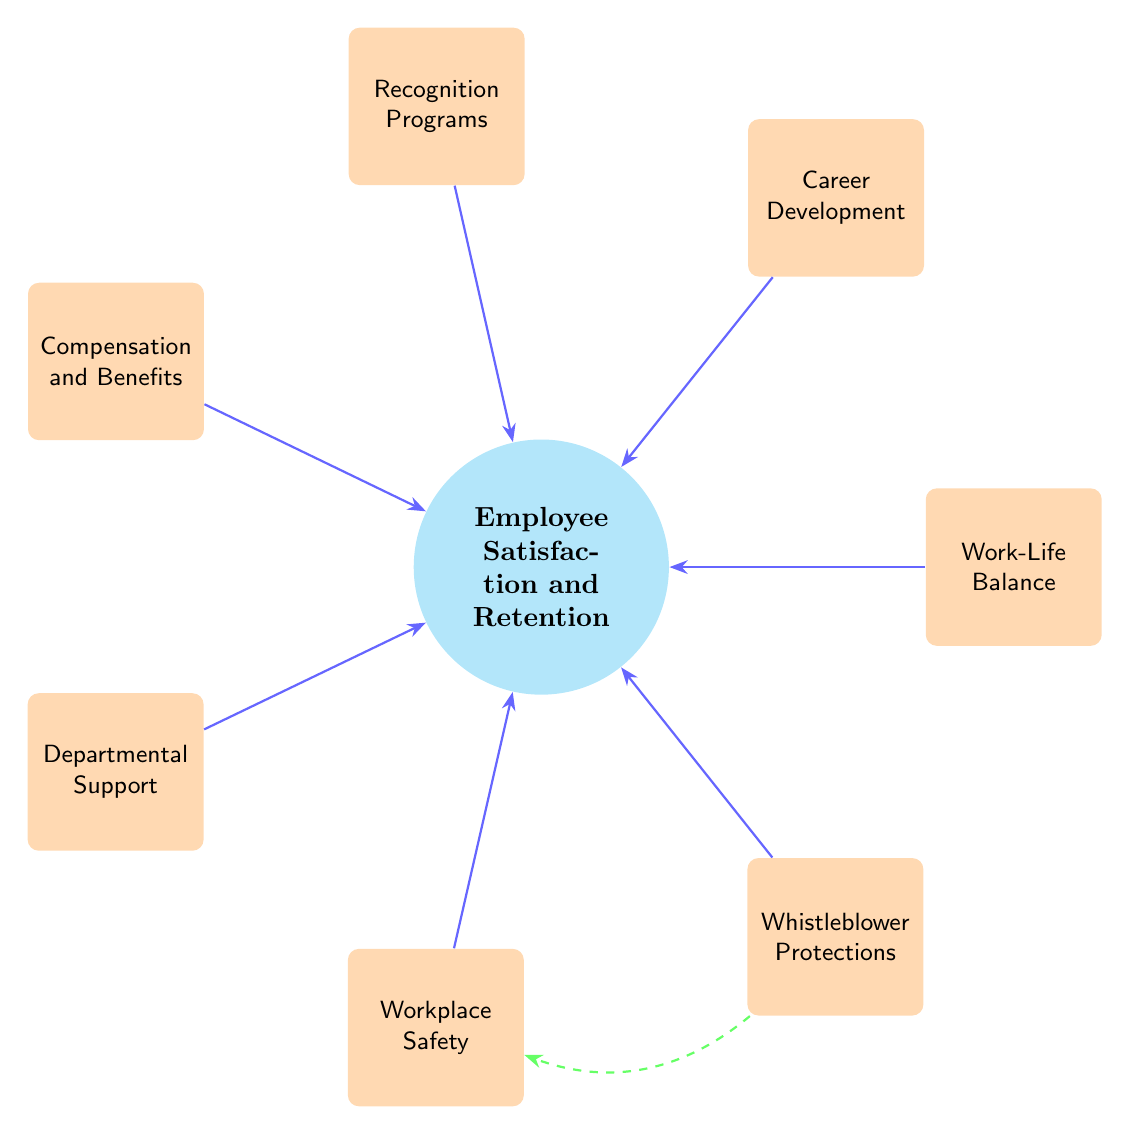What is the central theme of the diagram? The central theme is indicated by the central node labeled "Employee Satisfaction and Retention." This node is the focal point, connecting various factors that influence it.
Answer: Employee Satisfaction and Retention How many factors influence employee satisfaction and retention? There are seven factors surrounding the central node, each represented in the diagram, indicating their influence on employee satisfaction and retention.
Answer: Seven Which factor is associated with workplace safety? The factor specifically associated with workplace safety is labeled "Workplace Safety." It is positioned among the other influencing factors surrounding the central theme.
Answer: Workplace Safety What is the unique relationship highlighted in the diagram? The unique relationship is indicated by the dashed line between "Whistleblower Protections" and "Workplace Safety." This suggests a special, enhanced influence of whistleblower protections on workplace safety.
Answer: Whistleblower Protections to Workplace Safety Which two factors are linked with direct influence to the central theme? All factors including Work-Life Balance, Career Development, Recognition Programs, Compensation and Benefits, Departmental Support, Workplace Safety, and Whistleblower Protections have direct influence connections to the central theme.
Answer: All seven factors What color represents the core concept in the diagram? The core concept, which is "Employee Satisfaction and Retention," is filled with cyan color as represented in the diagram.
Answer: Cyan Which factor comes first in the counter-clockwise arrangement? The first factor in the counter-clockwise arrangement from the central theme is "Work-Life Balance," located at the 0-degree position.
Answer: Work-Life Balance 